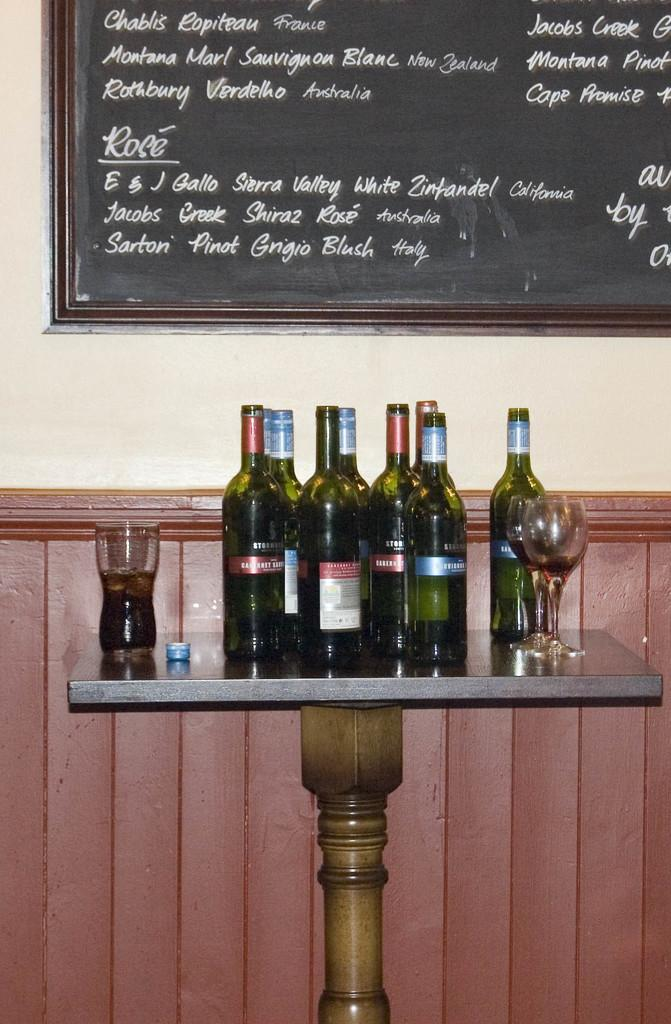Provide a one-sentence caption for the provided image. Jacobs and Montana are amongst the many names written on the chalkboard. 